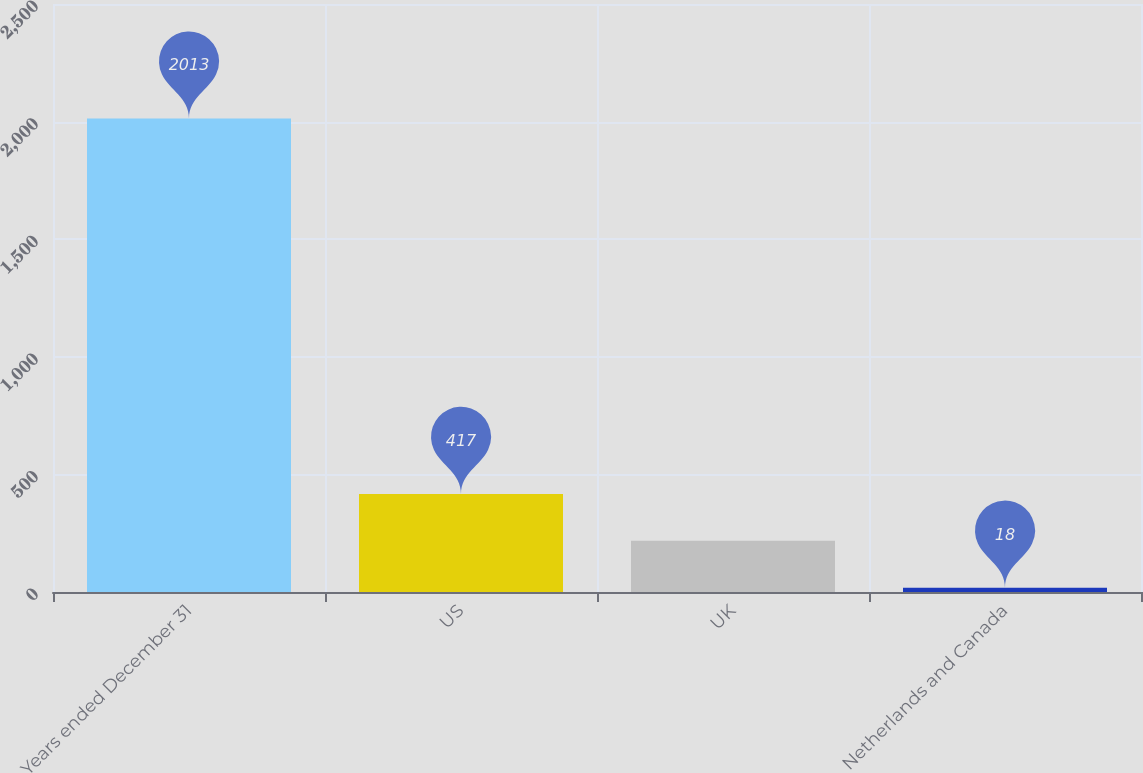Convert chart. <chart><loc_0><loc_0><loc_500><loc_500><bar_chart><fcel>Years ended December 31<fcel>US<fcel>UK<fcel>Netherlands and Canada<nl><fcel>2013<fcel>417<fcel>217.5<fcel>18<nl></chart> 